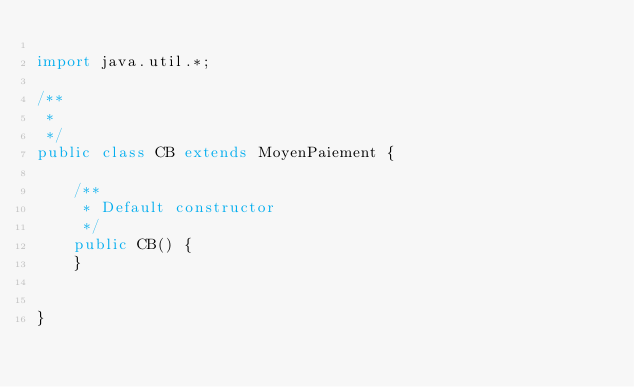Convert code to text. <code><loc_0><loc_0><loc_500><loc_500><_Java_>
import java.util.*;

/**
 * 
 */
public class CB extends MoyenPaiement {

    /**
     * Default constructor
     */
    public CB() {
    }


}</code> 